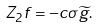Convert formula to latex. <formula><loc_0><loc_0><loc_500><loc_500>Z _ { 2 } f = - c \sigma \widetilde { g } .</formula> 